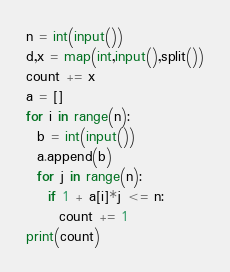Convert code to text. <code><loc_0><loc_0><loc_500><loc_500><_Python_>n = int(input())
d,x = map(int,input(),split())
count += x
a = []
for i in range(n):
  b = int(input())
  a.append(b)
  for j in range(n):
    if 1 + a[i]*j <= n:
      count += 1
print(count)</code> 